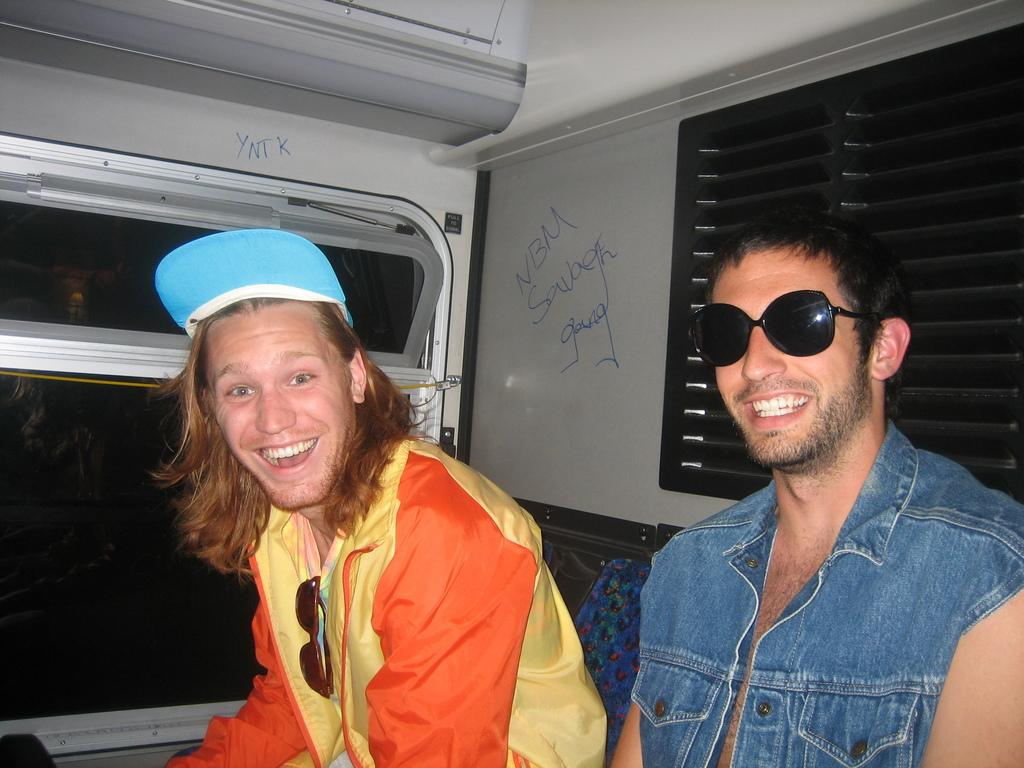How many people are in the image? There are two persons in the image. What are the persons doing in the image? Both persons are sitting. What expressions do the persons have in the image? Both persons are smiling. Can you describe any accessories worn by one of the persons? One person is wearing glasses. What type of architectural feature can be seen in the image? There is a glass window in the image. What type of egg can be seen in the image? There is no egg present in the image. 